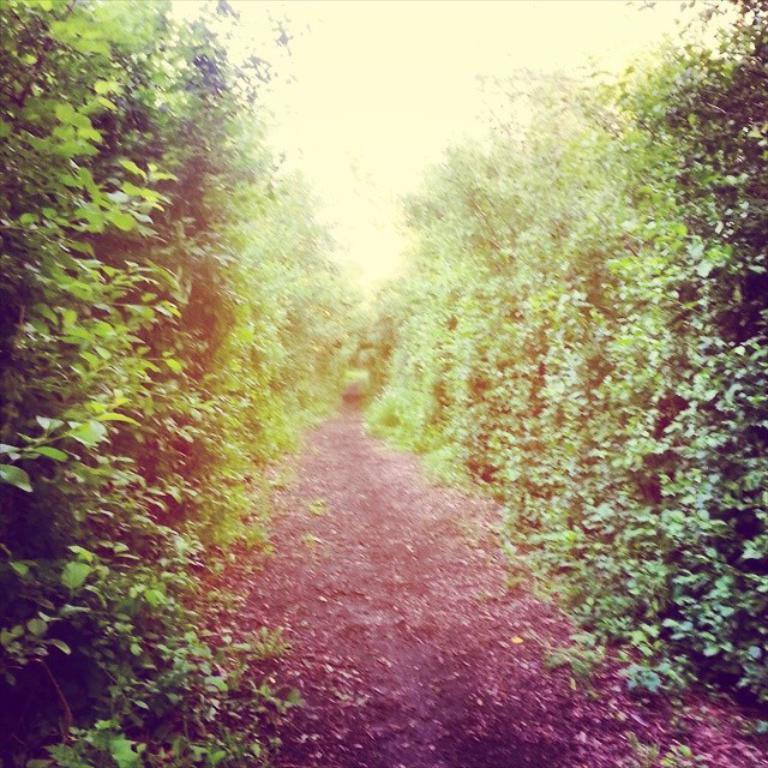What type of vegetation can be seen on both sides of the image? There are trees on the right side and the left side of the image. What is located in the center of the image? There is a path in the center of the image. What type of oatmeal is being served to the pet in the image? There is no oatmeal or pet present in the image; it features trees on both sides and a path in the center. 